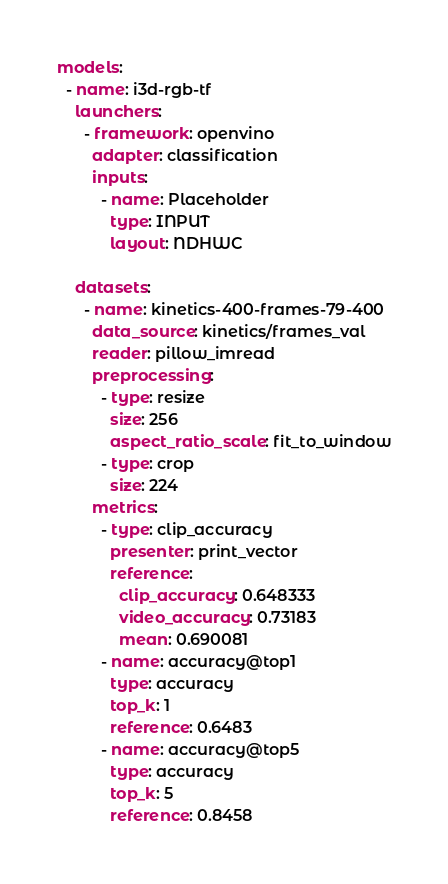Convert code to text. <code><loc_0><loc_0><loc_500><loc_500><_YAML_>models:
  - name: i3d-rgb-tf
    launchers:
      - framework: openvino
        adapter: classification
        inputs:
          - name: Placeholder
            type: INPUT
            layout: NDHWC

    datasets:
      - name: kinetics-400-frames-79-400
        data_source: kinetics/frames_val
        reader: pillow_imread
        preprocessing:
          - type: resize
            size: 256
            aspect_ratio_scale: fit_to_window
          - type: crop
            size: 224
        metrics:
          - type: clip_accuracy
            presenter: print_vector
            reference:
              clip_accuracy: 0.648333
              video_accuracy: 0.73183
              mean: 0.690081
          - name: accuracy@top1
            type: accuracy
            top_k: 1
            reference: 0.6483
          - name: accuracy@top5
            type: accuracy
            top_k: 5
            reference: 0.8458
</code> 